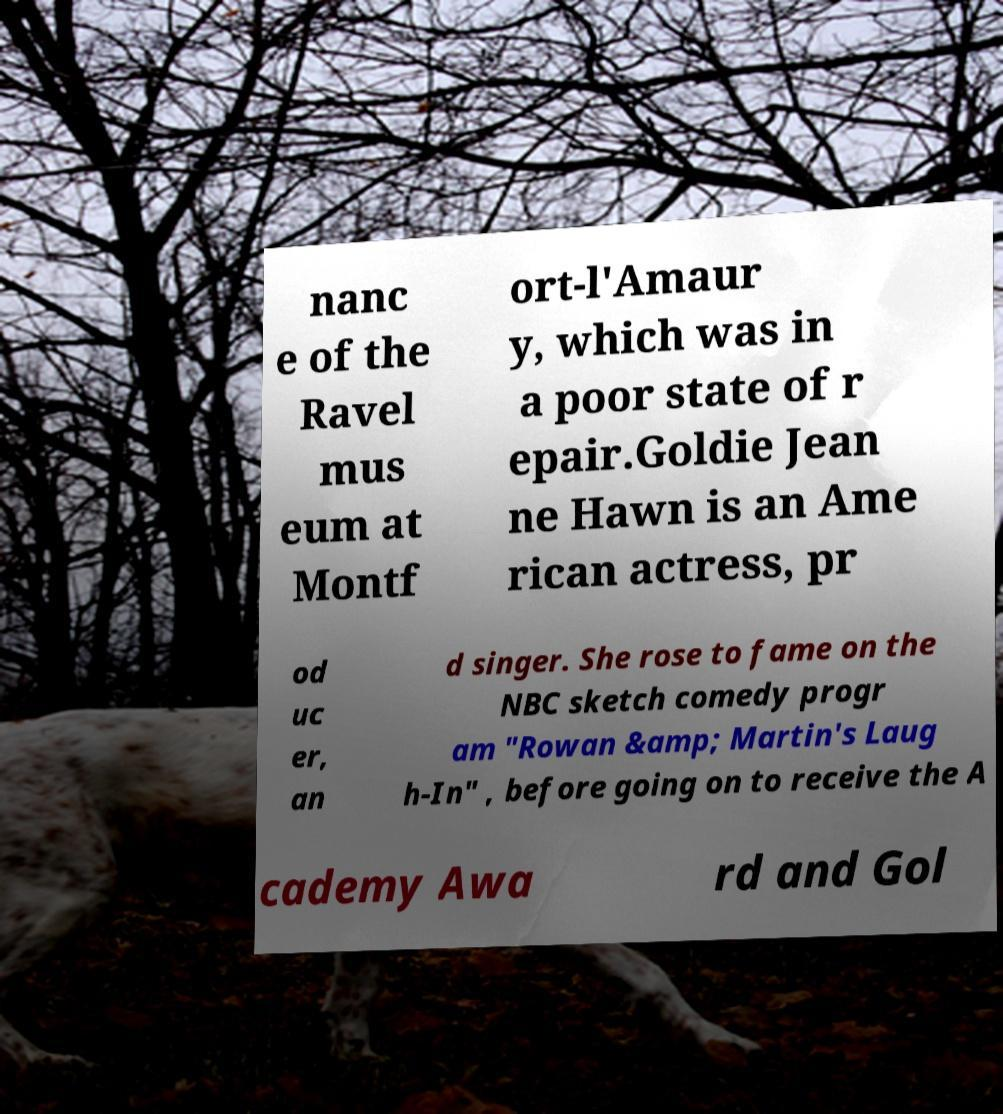There's text embedded in this image that I need extracted. Can you transcribe it verbatim? nanc e of the Ravel mus eum at Montf ort-l'Amaur y, which was in a poor state of r epair.Goldie Jean ne Hawn is an Ame rican actress, pr od uc er, an d singer. She rose to fame on the NBC sketch comedy progr am "Rowan &amp; Martin's Laug h-In" , before going on to receive the A cademy Awa rd and Gol 